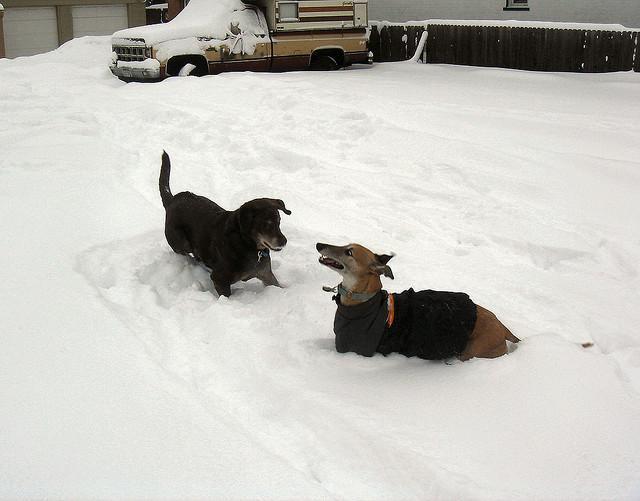How many dogs are playing in the snow?
Give a very brief answer. 2. How many dogs are there?
Give a very brief answer. 2. How many of the umbrellas are folded?
Give a very brief answer. 0. 